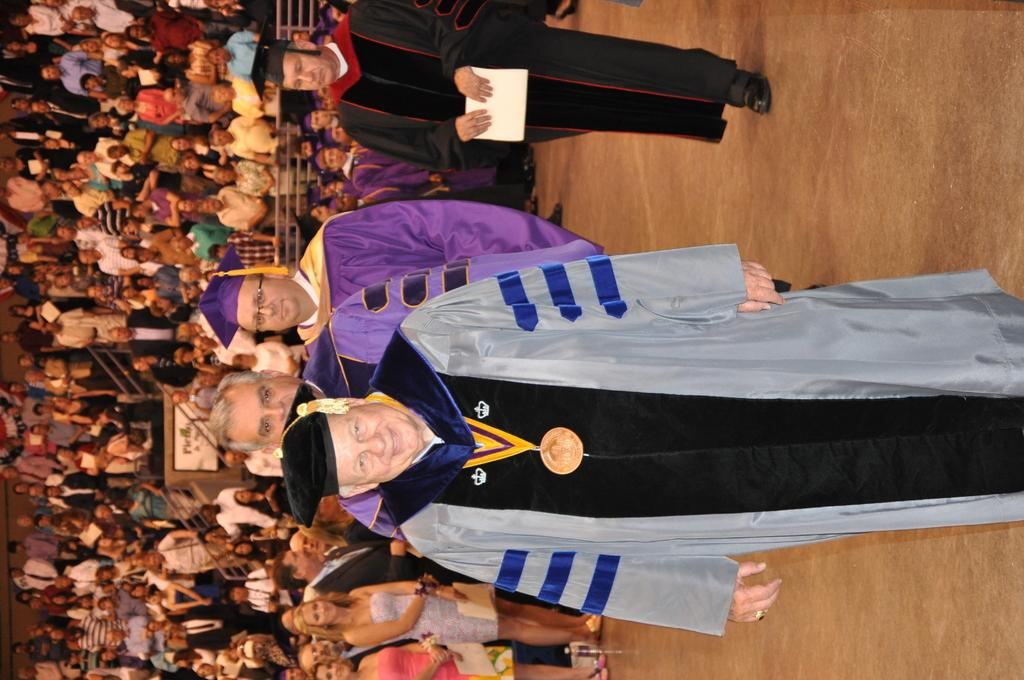What can be seen in the image? There is a group of people in the image. What else is present in the image? There are railings in the image. Can you describe the man at the top of the image? The man at the top of the image is holding a paper. What type of quill is the man using to write on the paper in the image? There is no quill present in the image; the man is holding a paper but not writing on it. 